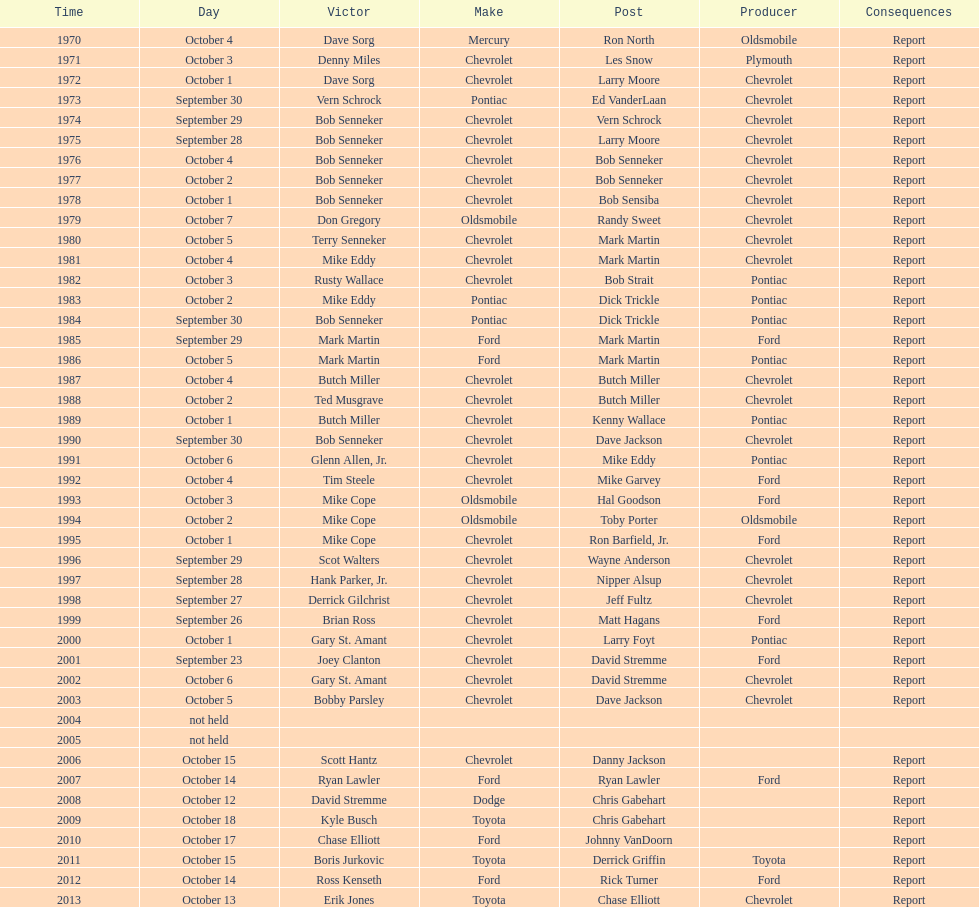Who on the list has the highest number of consecutive wins? Bob Senneker. 